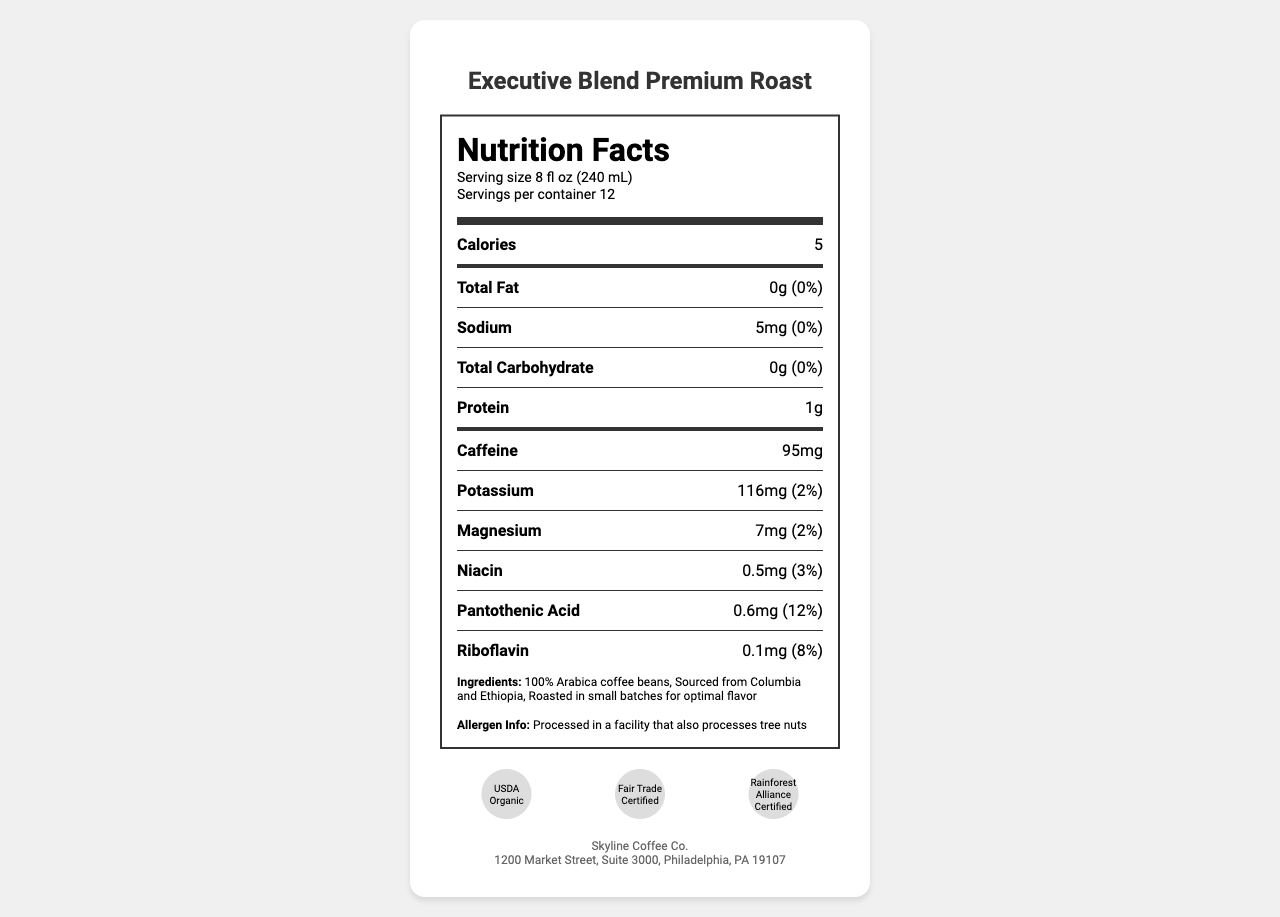what is the serving size? The serving size is specified at the top of the Nutrition Facts section under “Serving size”.
Answer: 8 fl oz (240 mL) how many calories are in one serving? The number of calories per serving is listed at the beginning of the Nutrition Facts.
Answer: 5 how much caffeine is in one serving? The amount of caffeine per serving is listed as one of the nutrients.
Answer: 95 mg what are the protein content and percentage daily value? The nutrition facts section lists the protein content as 1g per serving without a percentage daily value.
Answer: 1g does the product contain tree nuts? The allergen information states it is processed in a facility that also processes tree nuts but does not indicate the coffee itself contains them.
Answer: No what certifications does the coffee have? A. USDA Organic B. Fair Trade Certified C. Rainforest Alliance Certified D. All of the above All of the certifications are listed at the bottom of the document under certifications.
Answer: D what is the company name and address? The company info section at the end of the document lists the name and address.
Answer: Skyline Coffee Co., 1200 Market Street, Suite 3000, Philadelphia, PA 19107 what flavors are noted in the gourmet coffee blend? The flavor profile section describes the flavors.
Answer: Notes of dark chocolate, caramel, and a hint of citrus what is the roast level of the Executive Blend Premium Roast? The roast level is specified under the flavor profile section.
Answer: Medium-dark is the packaging environmentally friendly? The sustainability note mentions that the packaging is made from 30% post-consumer recycled materials.
Answer: Yes describe the main idea of the document The document includes standard nutritional facts, company contact information, and attributes aimed at appealing to customers in Class A office spaces, emphasizing the coffee's flavor and quality.
Answer: The document is a Nutrition Facts Label for "Executive Blend Premium Roast," a gourmet coffee blend sold in high-end office buildings. It provides detailed nutritional information, ingredient list, allergen info, certifications, and additional notes about its preparation, sustainability, and office building appeal. what is the total amount of potassium in two servings? The document provides the amount for one serving, but it does not include information on the total for multiple servings.
Answer: I don't know 